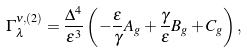<formula> <loc_0><loc_0><loc_500><loc_500>\Gamma _ { \lambda } ^ { \nu , ( 2 ) } = \frac { \Delta ^ { 4 } } { \varepsilon ^ { 3 } } \left ( - \frac { \varepsilon } { \gamma } A _ { g } + \frac { \gamma } { \varepsilon } B _ { g } + C _ { g } \right ) ,</formula> 